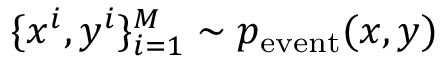Convert formula to latex. <formula><loc_0><loc_0><loc_500><loc_500>\{ x ^ { i } , y ^ { i } \} _ { i = 1 } ^ { M } \sim p _ { e v e n t } ( x , y )</formula> 